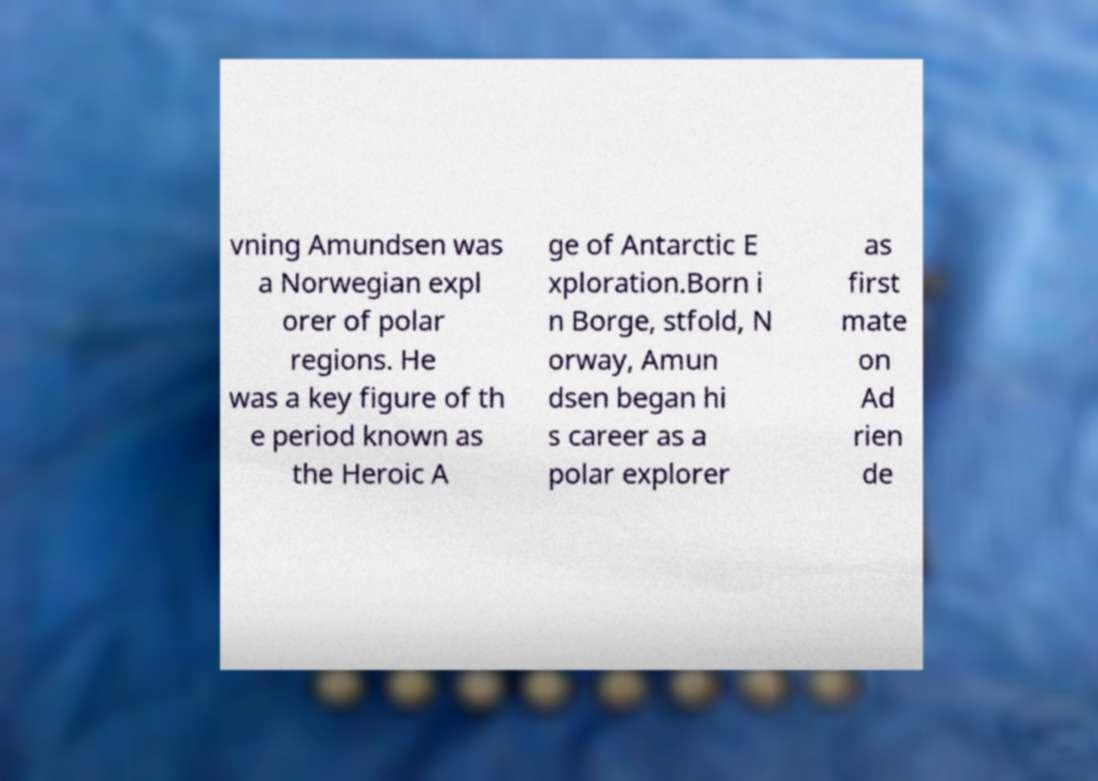Could you extract and type out the text from this image? vning Amundsen was a Norwegian expl orer of polar regions. He was a key figure of th e period known as the Heroic A ge of Antarctic E xploration.Born i n Borge, stfold, N orway, Amun dsen began hi s career as a polar explorer as first mate on Ad rien de 